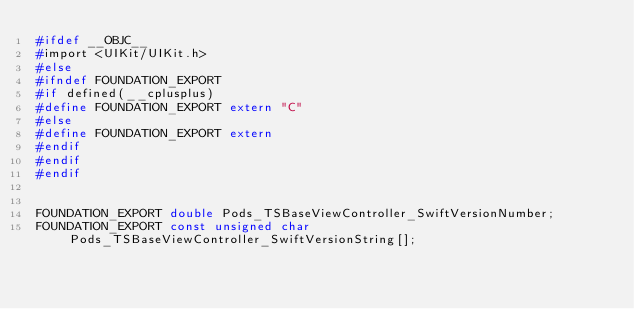Convert code to text. <code><loc_0><loc_0><loc_500><loc_500><_C_>#ifdef __OBJC__
#import <UIKit/UIKit.h>
#else
#ifndef FOUNDATION_EXPORT
#if defined(__cplusplus)
#define FOUNDATION_EXPORT extern "C"
#else
#define FOUNDATION_EXPORT extern
#endif
#endif
#endif


FOUNDATION_EXPORT double Pods_TSBaseViewController_SwiftVersionNumber;
FOUNDATION_EXPORT const unsigned char Pods_TSBaseViewController_SwiftVersionString[];

</code> 